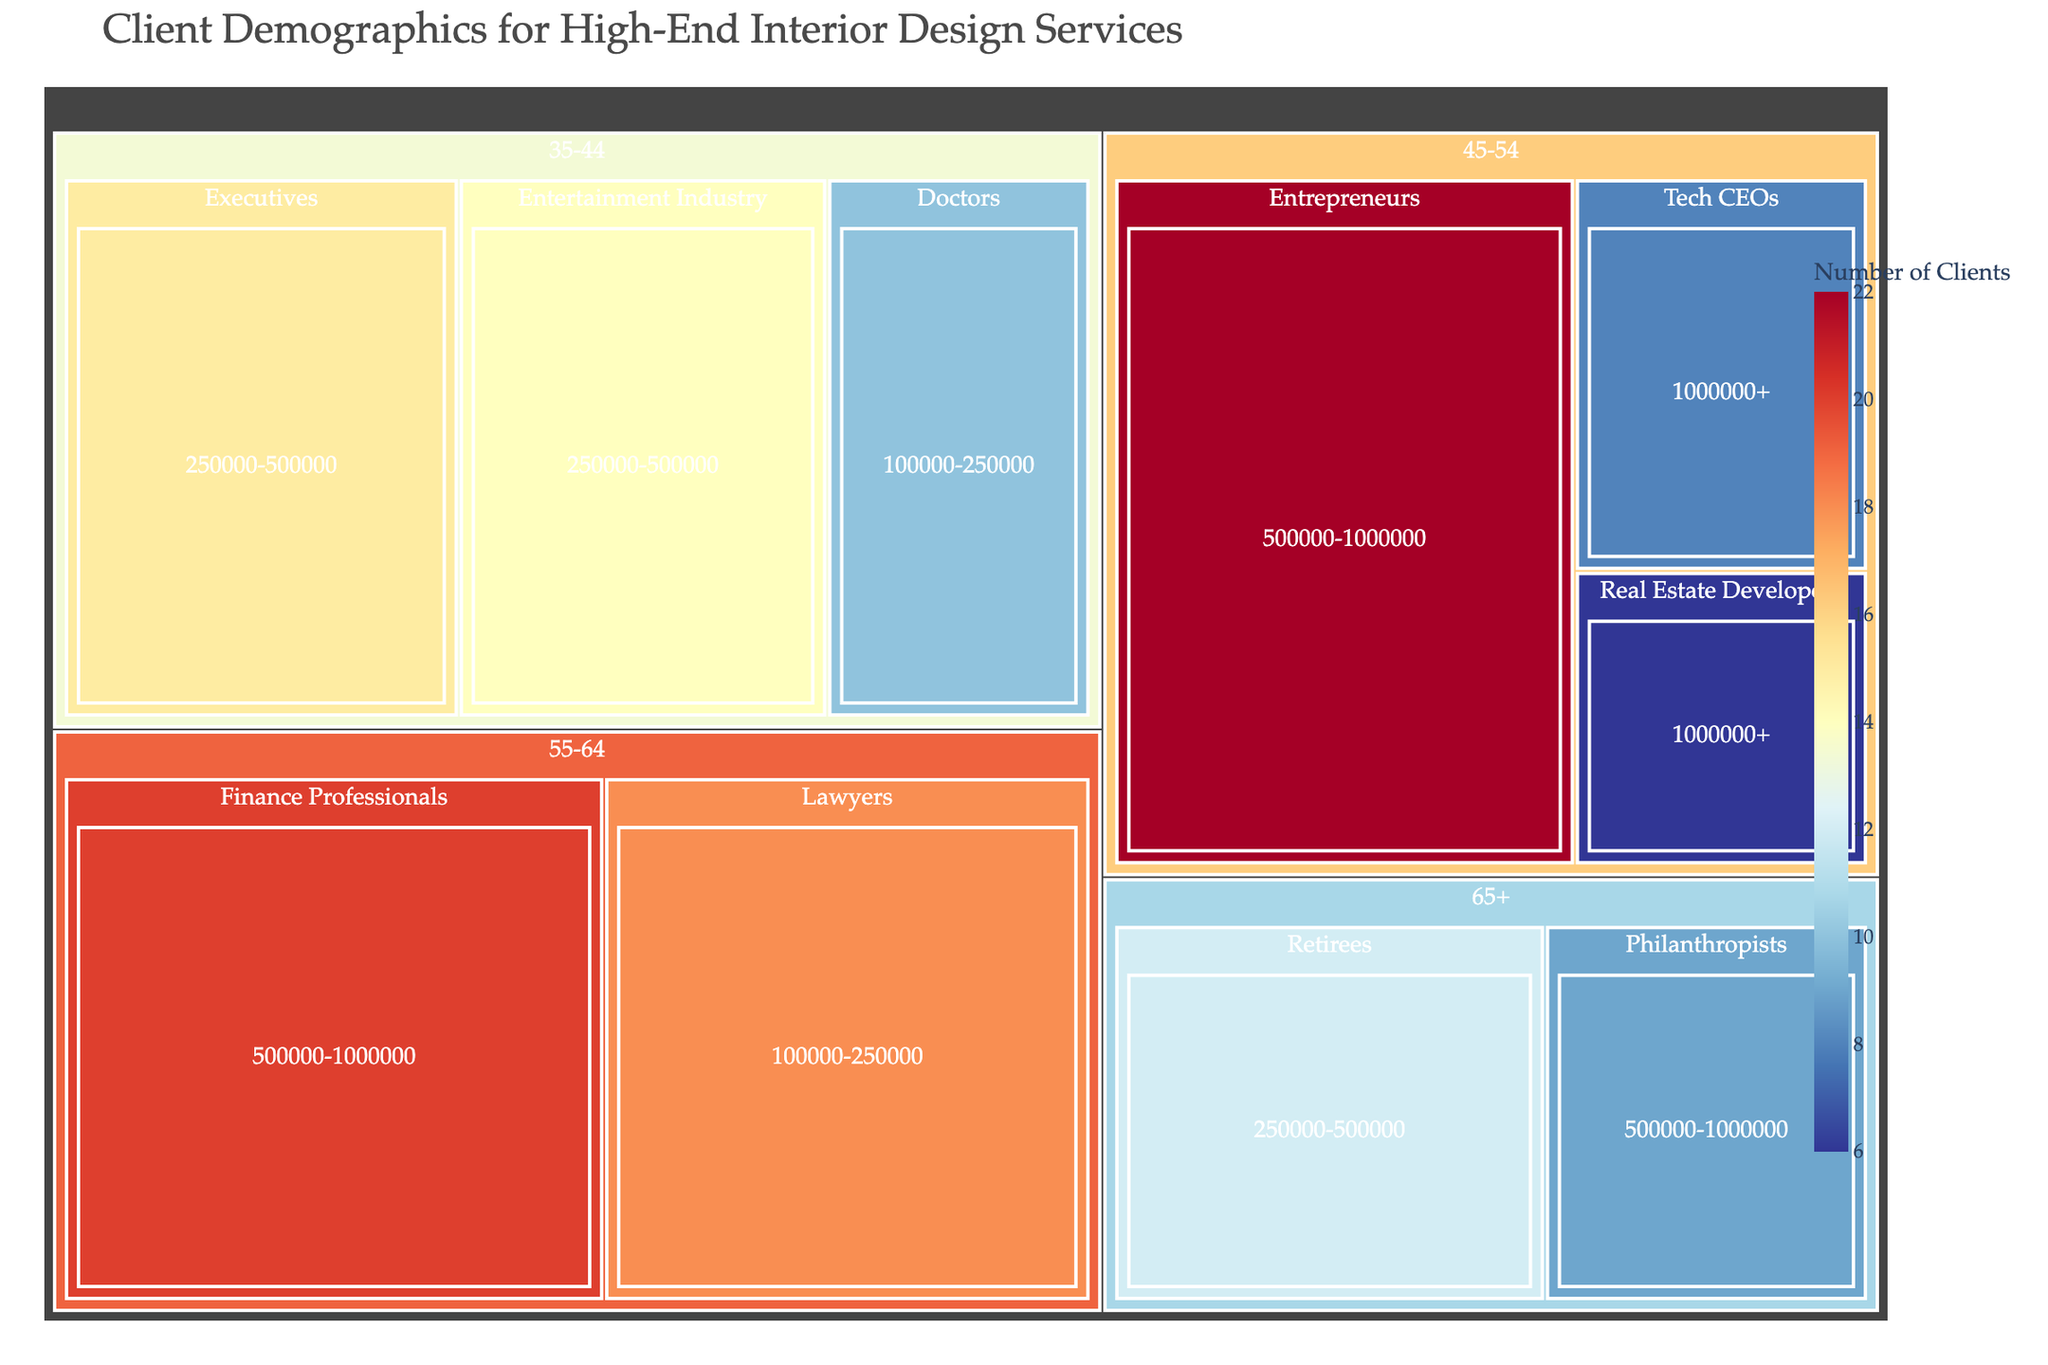what is the most common age group among the clients? The title indicates the data is about client demographics for high-end interior design services. Looking at the treemap, identify the largest block by the number of clients among the age groups.
Answer: 45-54 Which profession has the highest number of clients within the 55-64 age group? Navigate to the 55-64 age group section, check which professional subgroup has the largest block by the number of clients.
Answer: Finance Professionals What is the combined number of clients in the 35-44 age group? Identify all subgroups under the 35-44 age group, then add the number of clients for each: Executives (15), Doctors (10), Entertainment Industry (14). So, 15 + 10 + 14.
Answer: 39 How does the number of clients in the 65+ age group compare to the 45-54 age group? First, sum the number of clients in each profession within the 65+ age group: Retirees (12), Philanthropists (9). Total is 12 + 9. Then, sum the number of clients in each profession within the 45-54 age group: Entrepreneurs (22), Tech CEOs (8), Real Estate Developers (6). Total is 22 + 8 + 6. Compare these two totals.
Answer: 21 (65+) is less than 36 (45-54) In the 45-54 age group, which budget range has the highest number of clients? Look into the 45-54 age group, then find the budget range with the largest block labeled by the number of clients: 500000-1000000 (22 clients) versus 1000000+ (8 clients).
Answer: 500000-1000000 What is the total number of clients in the project budget range of 250000-500000? Sum the number of clients across all age groups within the 250000-500000 budget range: Executives (15), Entertainment Industry (14), Retirees (12). So, 15 + 14 + 12.
Answer: 41 What is the profession with the smallest number of clients in the 65+ age group? Within the 65+ age group, compare the Profession sub-blocks labeled as Retirees (12) and Philanthropists (9). Identify the smallest block.
Answer: Philanthropists Which age group has the broadest range of professions listed? By examining the number of different professions under each age group in the treemap, identify the one with the most distinct profession entries.
Answer: 45-54 